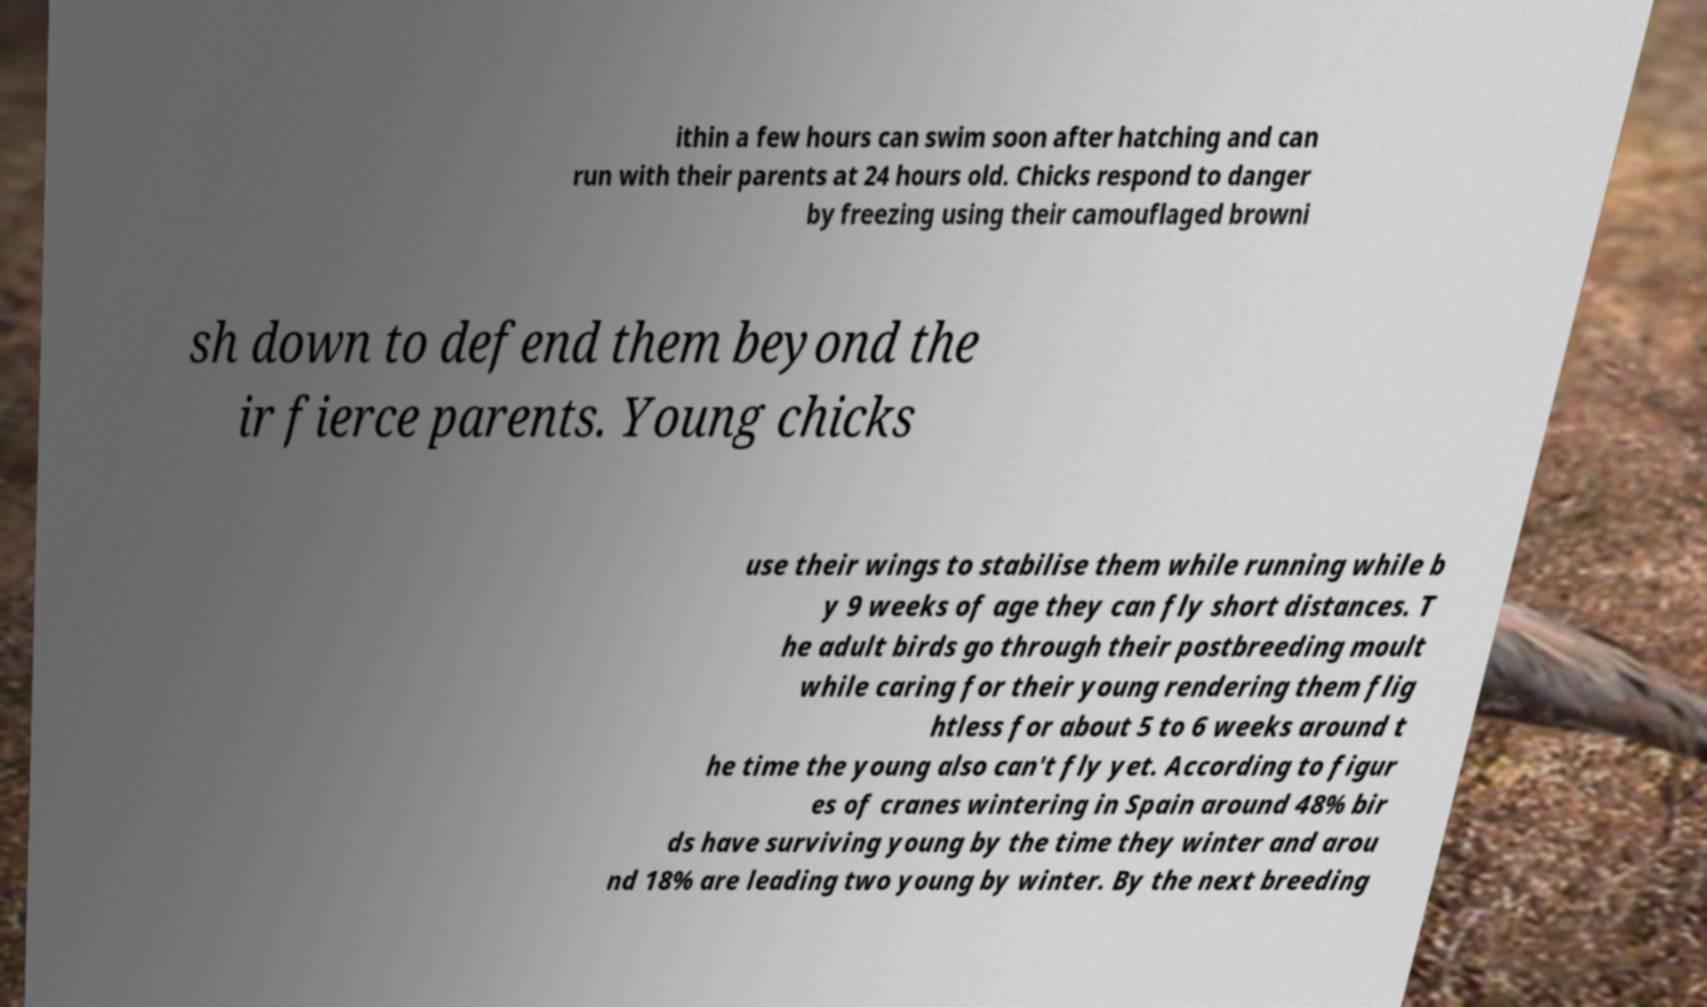What messages or text are displayed in this image? I need them in a readable, typed format. ithin a few hours can swim soon after hatching and can run with their parents at 24 hours old. Chicks respond to danger by freezing using their camouflaged browni sh down to defend them beyond the ir fierce parents. Young chicks use their wings to stabilise them while running while b y 9 weeks of age they can fly short distances. T he adult birds go through their postbreeding moult while caring for their young rendering them flig htless for about 5 to 6 weeks around t he time the young also can't fly yet. According to figur es of cranes wintering in Spain around 48% bir ds have surviving young by the time they winter and arou nd 18% are leading two young by winter. By the next breeding 